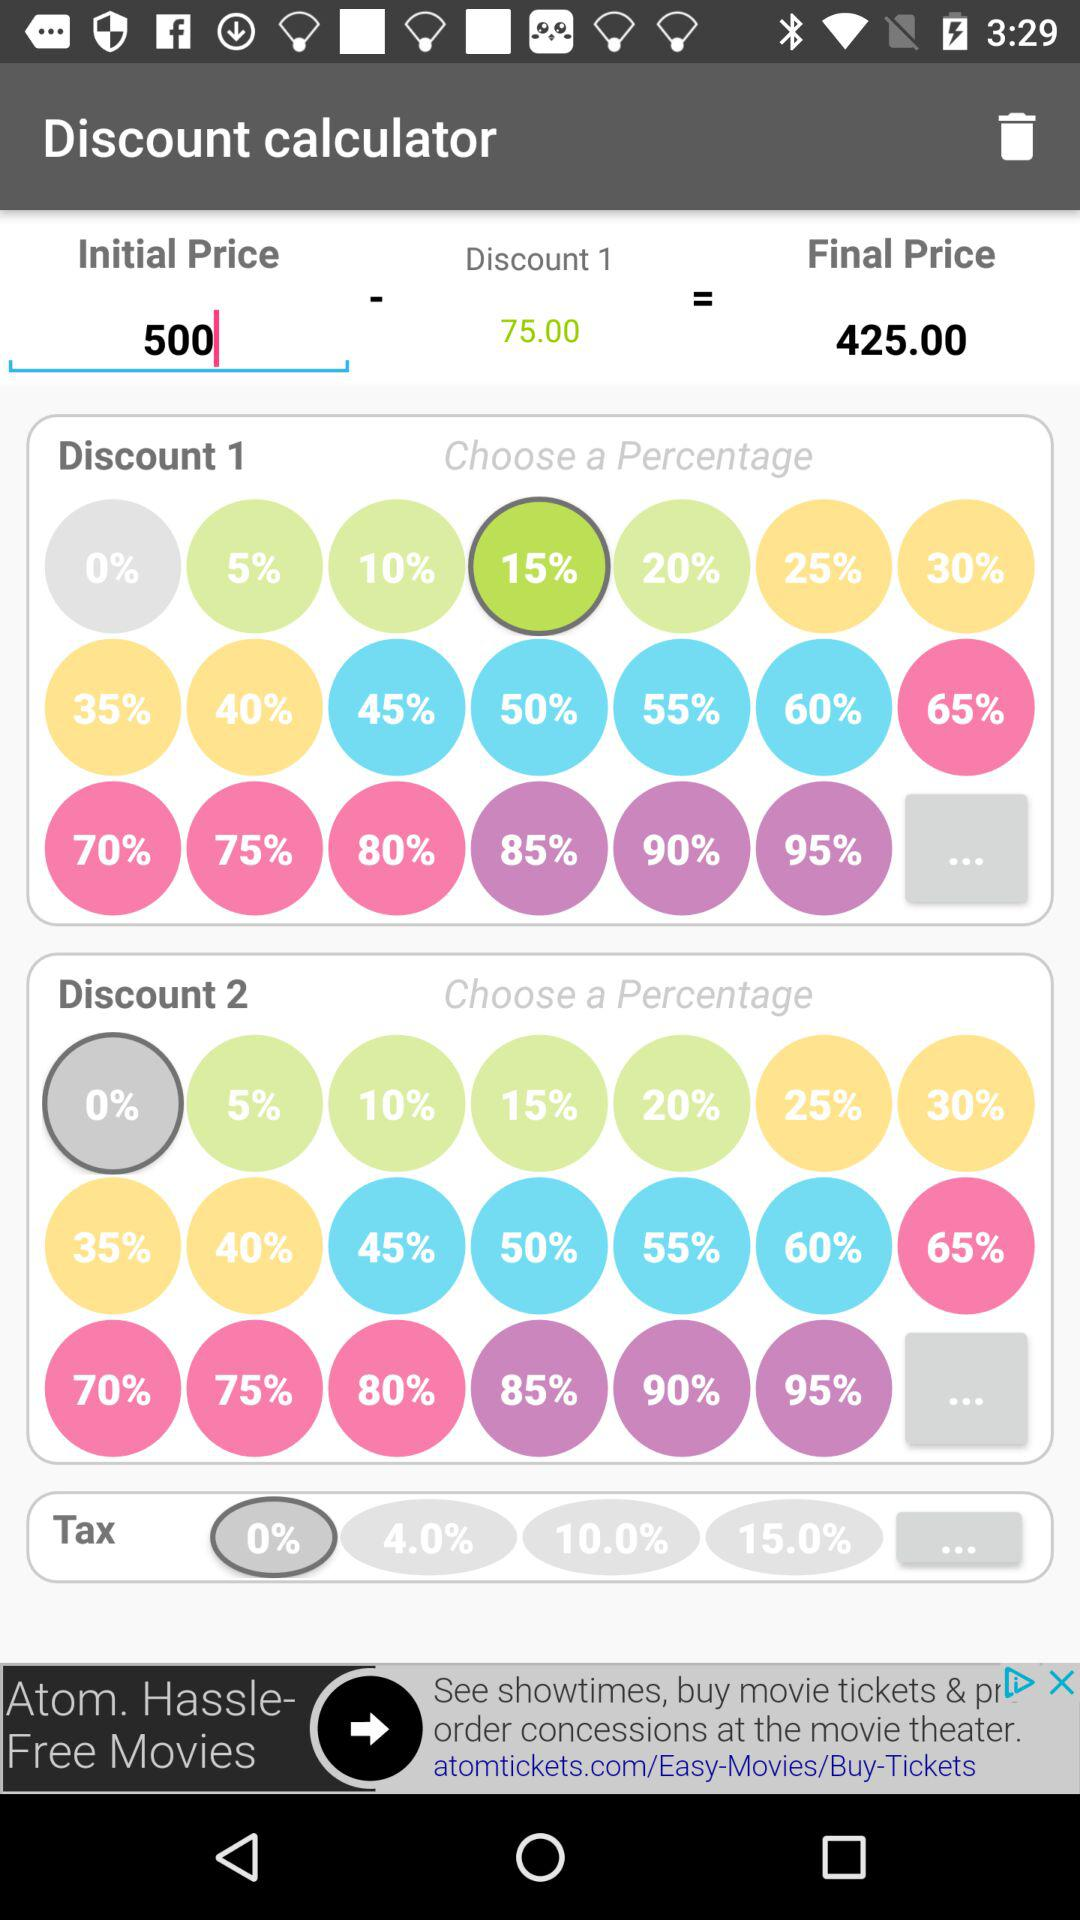What is the initial price? The initial price is 500. 